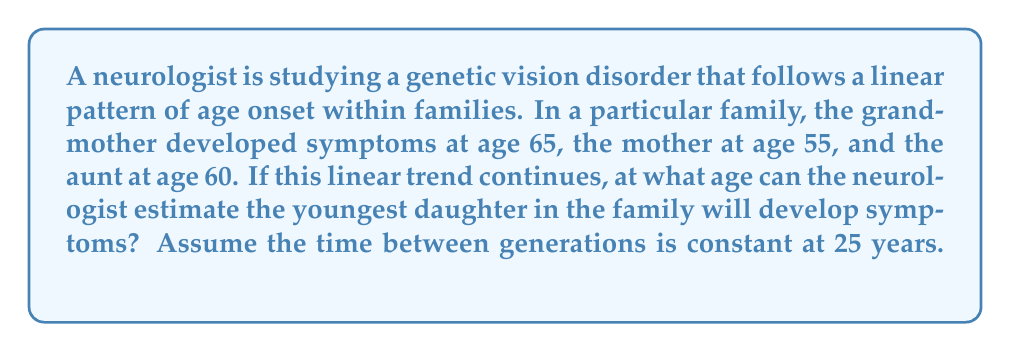Could you help me with this problem? Let's approach this step-by-step:

1) First, we need to establish our variables:
   Let $x$ represent the generation number
   Let $y$ represent the age of onset

2) We can plot the given data points:
   Grandmother: $(1, 65)$
   Mother: $(2, 55)$
   Aunt: $(1.5, 60)$ (assuming she's halfway between generations)

3) To find the linear equation, we'll use the slope-intercept form: $y = mx + b$

4) Calculate the slope $(m)$ using the grandmother and mother data points:
   $m = \frac{y_2 - y_1}{x_2 - x_1} = \frac{55 - 65}{2 - 1} = -10$

5) Now we can use either point to find $b$. Let's use the grandmother's data $(1, 65)$:
   $65 = -10(1) + b$
   $b = 75$

6) Our linear equation is: $y = -10x + 75$

7) The youngest daughter would be in the 3rd generation, so $x = 3$

8) Plug $x = 3$ into our equation:
   $y = -10(3) + 75 = 45$

Therefore, the neurologist can estimate that the youngest daughter will develop symptoms at age 45.
Answer: 45 years old 